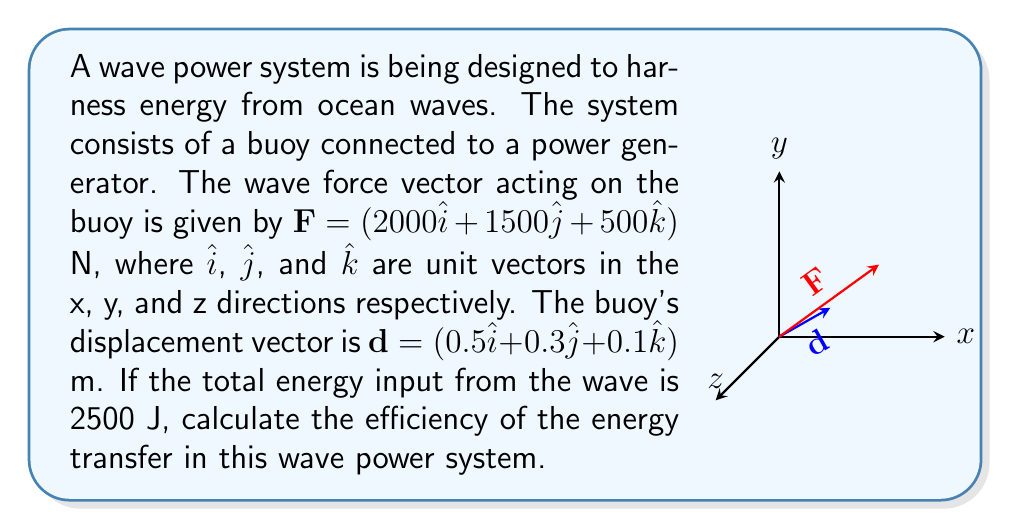Teach me how to tackle this problem. Let's approach this step-by-step:

1) The work done by the wave force on the buoy is given by the dot product of the force vector and the displacement vector:

   $W = \mathbf{F} \cdot \mathbf{d}$

2) Let's calculate this dot product:
   
   $W = (2000\hat{i} + 1500\hat{j} + 500\hat{k}) \cdot (0.5\hat{i} + 0.3\hat{j} + 0.1\hat{k})$
   
   $W = (2000 \times 0.5) + (1500 \times 0.3) + (500 \times 0.1)$
   
   $W = 1000 + 450 + 50 = 1500$ J

3) The efficiency of energy transfer is the ratio of useful work output to total energy input:

   $\text{Efficiency} = \frac{\text{Work Output}}{\text{Total Energy Input}} \times 100\%$

4) Substituting our values:

   $\text{Efficiency} = \frac{1500 \text{ J}}{2500 \text{ J}} \times 100\% = 0.6 \times 100\% = 60\%$

Therefore, the efficiency of the energy transfer in this wave power system is 60%.
Answer: 60% 